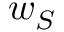Convert formula to latex. <formula><loc_0><loc_0><loc_500><loc_500>w _ { S }</formula> 